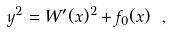<formula> <loc_0><loc_0><loc_500><loc_500>y ^ { 2 } = W ^ { \prime } ( x ) ^ { 2 } + f _ { 0 } ( x ) \ ,</formula> 